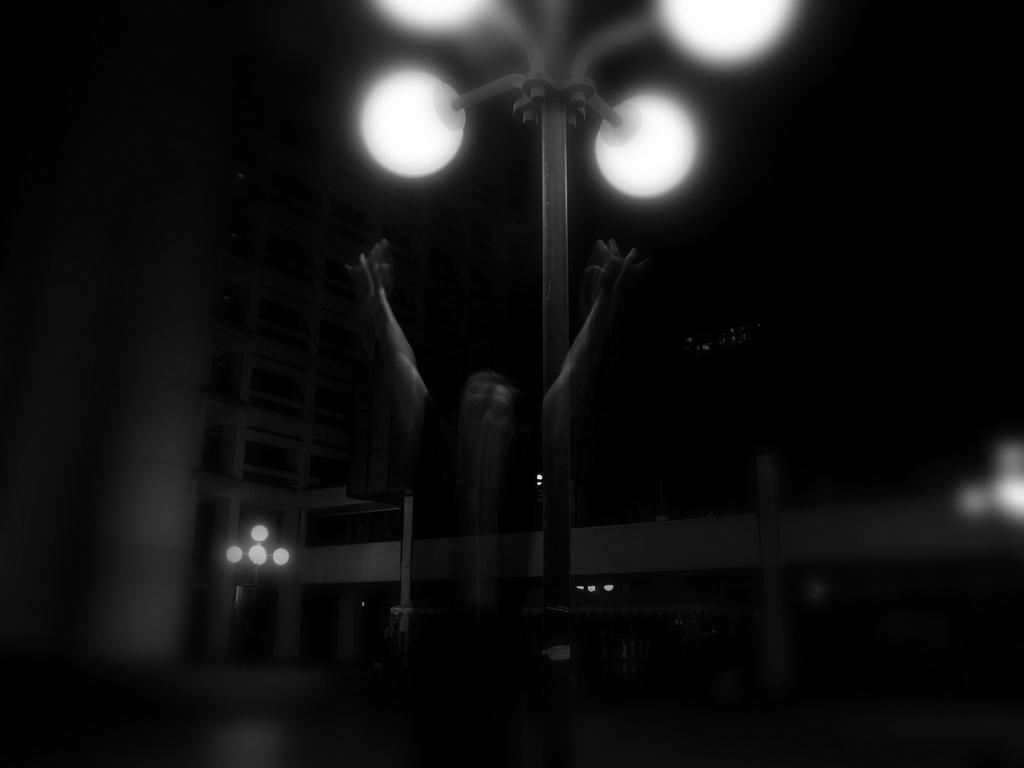Please provide a concise description of this image. This is a black and white picture. I can see a soul, there are lights, poles and there is a building. 